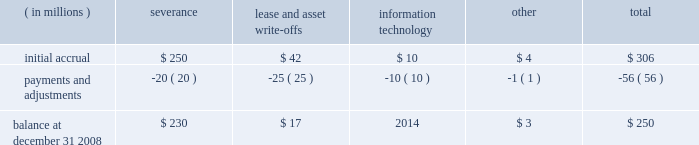As described above , the borrowings are extended on a non-recourse basis .
As such , there is no credit or market risk exposure to us on the assets , and as a result the terms of the amlf permit exclusion of the assets from regulatory leverage and risk-based capital calculations .
The interest rate on the borrowings is set by the federal reserve bank , and we earn net interest revenue by earning a spread on the difference between the yield we earn on the assets and the rate we pay on the borrowings .
For 2008 , we earned net interest revenue associated with this facility of approximately $ 68 million .
Separately , we currently maintain a commercial paper program under which we can issue up to $ 3 billion with original maturities of up to 270 days from the date of issue .
At december 31 , 2008 and 2007 , $ 2.59 billion and $ 2.36 billion , respectively , of commercial paper were outstanding .
In addition , state street bank currently has board authority to issue bank notes up to an aggregate of $ 5 billion , including up to $ 2.48 billion of senior notes under the fdic 2019s temporary liquidity guarantee program , instituted by the fdic in october 2008 for qualified senior debt issued through june 30 , 2009 , and up to $ 1 billion of subordinated bank notes ( see note 10 ) .
At december 31 , 2008 and 2007 , no notes payable were outstanding , and at december 31 , 2008 , all $ 5 billion was available for issuance .
State street bank currently maintains a line of credit of cad $ 800 million , or approximately $ 657 million , to support its canadian securities processing operations .
The line of credit has no stated termination date and is cancelable by either party with prior notice .
At december 31 , 2008 , no balance was due on this line of credit .
Note 9 .
Restructuring charges in december 2008 , we implemented a plan to reduce our expenses from operations and support our long- term growth .
In connection with this plan , we recorded aggregate restructuring charges of $ 306 million in our consolidated statement of income .
The primary component of the plan was an involuntary reduction of approximately 7% ( 7 % ) of our global workforce , which reduction we expect to be substantially completed by the end of the first quarter of 2009 .
Other components of the plan included costs related to lease and software license terminations , restructuring of agreements with technology providers and other costs .
Of the aggregate restructuring charges of $ 306 million , $ 243 million related to severance , a portion of which will be paid in a lump sum or over a defined period , and a portion of which will provide related benefits and outplacement services for approximately 2100 employees identified for involuntary termination in connection with the plan ; $ 49 million related to future lease obligations and write-offs of capitalized assets , including $ 23 million for impairment of other intangible assets ; $ 10 million of costs associated with information technology and $ 4 million of other restructuring costs .
The severance component included $ 47 million related to accelerated vesting of equity-based compensation .
In december 2008 , approximately 620 employees were involuntarily terminated and left state street .
The table presents the activity in the related balance sheet reserve for 2008 .
( in millions ) severance lease and write-offs information technology other total .

What is the percentage change in the balance of the outstanding commercial papers from 2007 to 2008? 
Computations: ((2.59 - 2.36) / 2.36)
Answer: 0.09746. As described above , the borrowings are extended on a non-recourse basis .
As such , there is no credit or market risk exposure to us on the assets , and as a result the terms of the amlf permit exclusion of the assets from regulatory leverage and risk-based capital calculations .
The interest rate on the borrowings is set by the federal reserve bank , and we earn net interest revenue by earning a spread on the difference between the yield we earn on the assets and the rate we pay on the borrowings .
For 2008 , we earned net interest revenue associated with this facility of approximately $ 68 million .
Separately , we currently maintain a commercial paper program under which we can issue up to $ 3 billion with original maturities of up to 270 days from the date of issue .
At december 31 , 2008 and 2007 , $ 2.59 billion and $ 2.36 billion , respectively , of commercial paper were outstanding .
In addition , state street bank currently has board authority to issue bank notes up to an aggregate of $ 5 billion , including up to $ 2.48 billion of senior notes under the fdic 2019s temporary liquidity guarantee program , instituted by the fdic in october 2008 for qualified senior debt issued through june 30 , 2009 , and up to $ 1 billion of subordinated bank notes ( see note 10 ) .
At december 31 , 2008 and 2007 , no notes payable were outstanding , and at december 31 , 2008 , all $ 5 billion was available for issuance .
State street bank currently maintains a line of credit of cad $ 800 million , or approximately $ 657 million , to support its canadian securities processing operations .
The line of credit has no stated termination date and is cancelable by either party with prior notice .
At december 31 , 2008 , no balance was due on this line of credit .
Note 9 .
Restructuring charges in december 2008 , we implemented a plan to reduce our expenses from operations and support our long- term growth .
In connection with this plan , we recorded aggregate restructuring charges of $ 306 million in our consolidated statement of income .
The primary component of the plan was an involuntary reduction of approximately 7% ( 7 % ) of our global workforce , which reduction we expect to be substantially completed by the end of the first quarter of 2009 .
Other components of the plan included costs related to lease and software license terminations , restructuring of agreements with technology providers and other costs .
Of the aggregate restructuring charges of $ 306 million , $ 243 million related to severance , a portion of which will be paid in a lump sum or over a defined period , and a portion of which will provide related benefits and outplacement services for approximately 2100 employees identified for involuntary termination in connection with the plan ; $ 49 million related to future lease obligations and write-offs of capitalized assets , including $ 23 million for impairment of other intangible assets ; $ 10 million of costs associated with information technology and $ 4 million of other restructuring costs .
The severance component included $ 47 million related to accelerated vesting of equity-based compensation .
In december 2008 , approximately 620 employees were involuntarily terminated and left state street .
The table presents the activity in the related balance sheet reserve for 2008 .
( in millions ) severance lease and write-offs information technology other total .

What value of cad is equal to $ 1 usd? 
Rationale: simple , but it is important to be able to do this type of currency translation.\\nwhat is the exchange rate between cad and usd ( $ ) ? - this was the original question but i changed to match formatting
Computations: (800 / 657)
Answer: 1.21766. As described above , the borrowings are extended on a non-recourse basis .
As such , there is no credit or market risk exposure to us on the assets , and as a result the terms of the amlf permit exclusion of the assets from regulatory leverage and risk-based capital calculations .
The interest rate on the borrowings is set by the federal reserve bank , and we earn net interest revenue by earning a spread on the difference between the yield we earn on the assets and the rate we pay on the borrowings .
For 2008 , we earned net interest revenue associated with this facility of approximately $ 68 million .
Separately , we currently maintain a commercial paper program under which we can issue up to $ 3 billion with original maturities of up to 270 days from the date of issue .
At december 31 , 2008 and 2007 , $ 2.59 billion and $ 2.36 billion , respectively , of commercial paper were outstanding .
In addition , state street bank currently has board authority to issue bank notes up to an aggregate of $ 5 billion , including up to $ 2.48 billion of senior notes under the fdic 2019s temporary liquidity guarantee program , instituted by the fdic in october 2008 for qualified senior debt issued through june 30 , 2009 , and up to $ 1 billion of subordinated bank notes ( see note 10 ) .
At december 31 , 2008 and 2007 , no notes payable were outstanding , and at december 31 , 2008 , all $ 5 billion was available for issuance .
State street bank currently maintains a line of credit of cad $ 800 million , or approximately $ 657 million , to support its canadian securities processing operations .
The line of credit has no stated termination date and is cancelable by either party with prior notice .
At december 31 , 2008 , no balance was due on this line of credit .
Note 9 .
Restructuring charges in december 2008 , we implemented a plan to reduce our expenses from operations and support our long- term growth .
In connection with this plan , we recorded aggregate restructuring charges of $ 306 million in our consolidated statement of income .
The primary component of the plan was an involuntary reduction of approximately 7% ( 7 % ) of our global workforce , which reduction we expect to be substantially completed by the end of the first quarter of 2009 .
Other components of the plan included costs related to lease and software license terminations , restructuring of agreements with technology providers and other costs .
Of the aggregate restructuring charges of $ 306 million , $ 243 million related to severance , a portion of which will be paid in a lump sum or over a defined period , and a portion of which will provide related benefits and outplacement services for approximately 2100 employees identified for involuntary termination in connection with the plan ; $ 49 million related to future lease obligations and write-offs of capitalized assets , including $ 23 million for impairment of other intangible assets ; $ 10 million of costs associated with information technology and $ 4 million of other restructuring costs .
The severance component included $ 47 million related to accelerated vesting of equity-based compensation .
In december 2008 , approximately 620 employees were involuntarily terminated and left state street .
The table presents the activity in the related balance sheet reserve for 2008 .
( in millions ) severance lease and write-offs information technology other total .

What percent of severence was paid off in 2008? 
Computations: (20 / 250)
Answer: 0.08. 